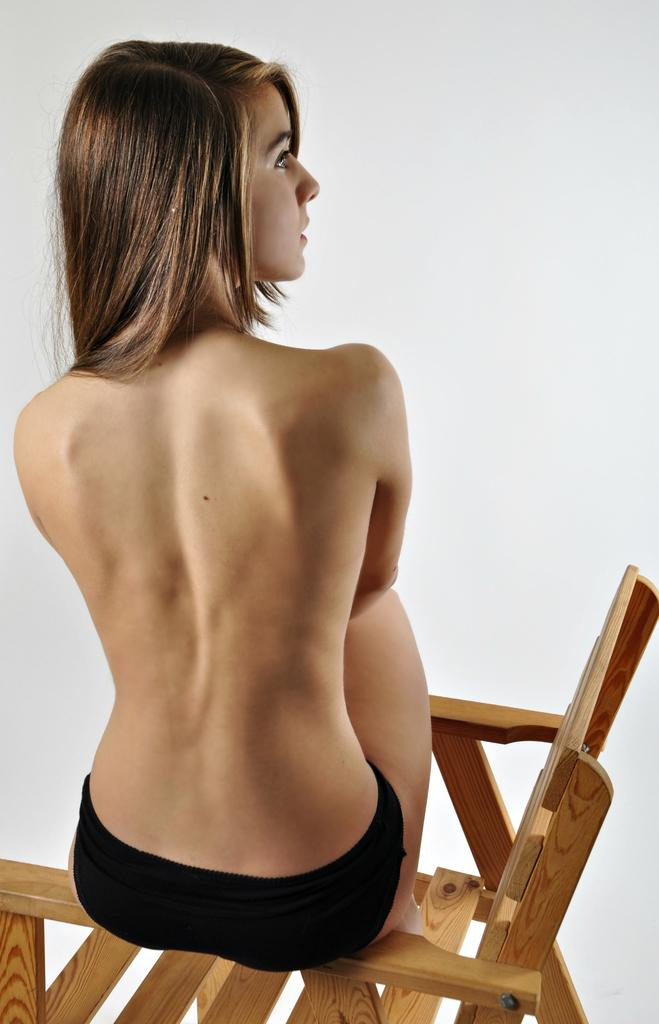Who is present in the image? There is a woman in the image. What is the woman doing in the image? The woman is sitting on a wooden chair. What type of lead is the woman holding in the image? There is no lead present in the image. The woman is simply sitting on a wooden chair. 